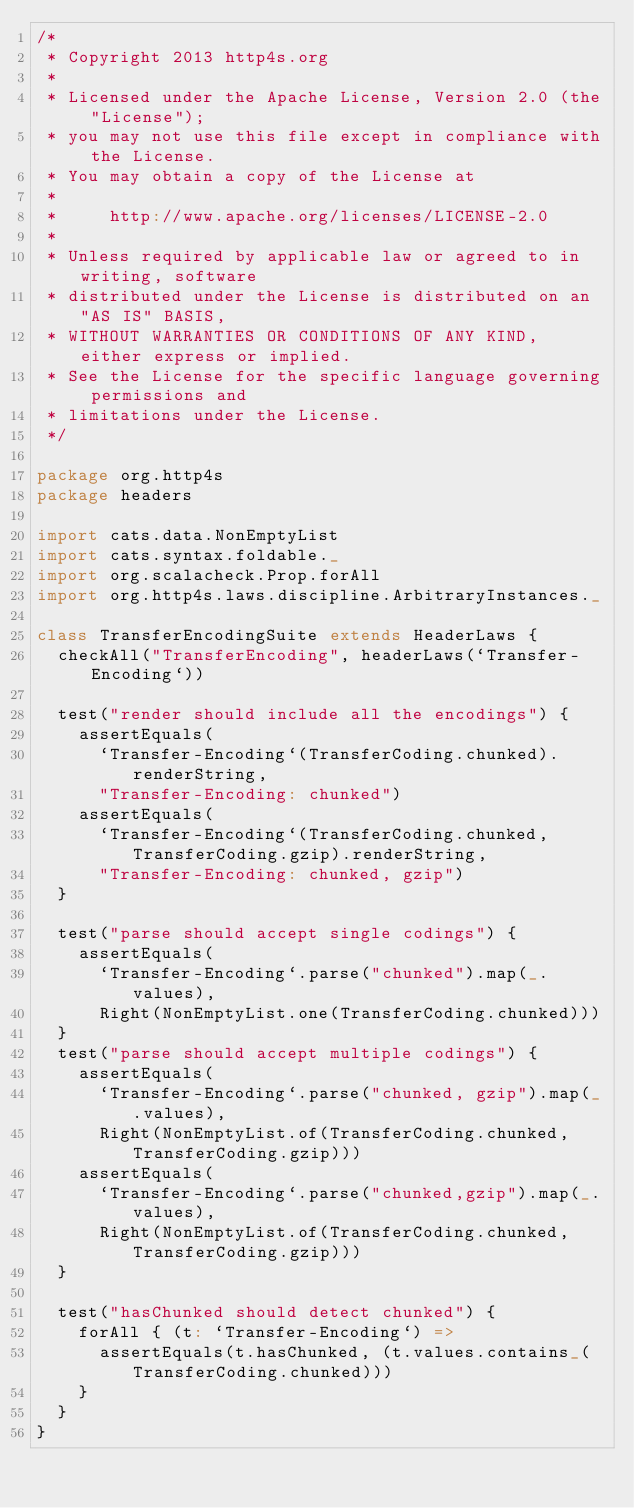Convert code to text. <code><loc_0><loc_0><loc_500><loc_500><_Scala_>/*
 * Copyright 2013 http4s.org
 *
 * Licensed under the Apache License, Version 2.0 (the "License");
 * you may not use this file except in compliance with the License.
 * You may obtain a copy of the License at
 *
 *     http://www.apache.org/licenses/LICENSE-2.0
 *
 * Unless required by applicable law or agreed to in writing, software
 * distributed under the License is distributed on an "AS IS" BASIS,
 * WITHOUT WARRANTIES OR CONDITIONS OF ANY KIND, either express or implied.
 * See the License for the specific language governing permissions and
 * limitations under the License.
 */

package org.http4s
package headers

import cats.data.NonEmptyList
import cats.syntax.foldable._
import org.scalacheck.Prop.forAll
import org.http4s.laws.discipline.ArbitraryInstances._

class TransferEncodingSuite extends HeaderLaws {
  checkAll("TransferEncoding", headerLaws(`Transfer-Encoding`))

  test("render should include all the encodings") {
    assertEquals(
      `Transfer-Encoding`(TransferCoding.chunked).renderString,
      "Transfer-Encoding: chunked")
    assertEquals(
      `Transfer-Encoding`(TransferCoding.chunked, TransferCoding.gzip).renderString,
      "Transfer-Encoding: chunked, gzip")
  }

  test("parse should accept single codings") {
    assertEquals(
      `Transfer-Encoding`.parse("chunked").map(_.values),
      Right(NonEmptyList.one(TransferCoding.chunked)))
  }
  test("parse should accept multiple codings") {
    assertEquals(
      `Transfer-Encoding`.parse("chunked, gzip").map(_.values),
      Right(NonEmptyList.of(TransferCoding.chunked, TransferCoding.gzip)))
    assertEquals(
      `Transfer-Encoding`.parse("chunked,gzip").map(_.values),
      Right(NonEmptyList.of(TransferCoding.chunked, TransferCoding.gzip)))
  }

  test("hasChunked should detect chunked") {
    forAll { (t: `Transfer-Encoding`) =>
      assertEquals(t.hasChunked, (t.values.contains_(TransferCoding.chunked)))
    }
  }
}
</code> 